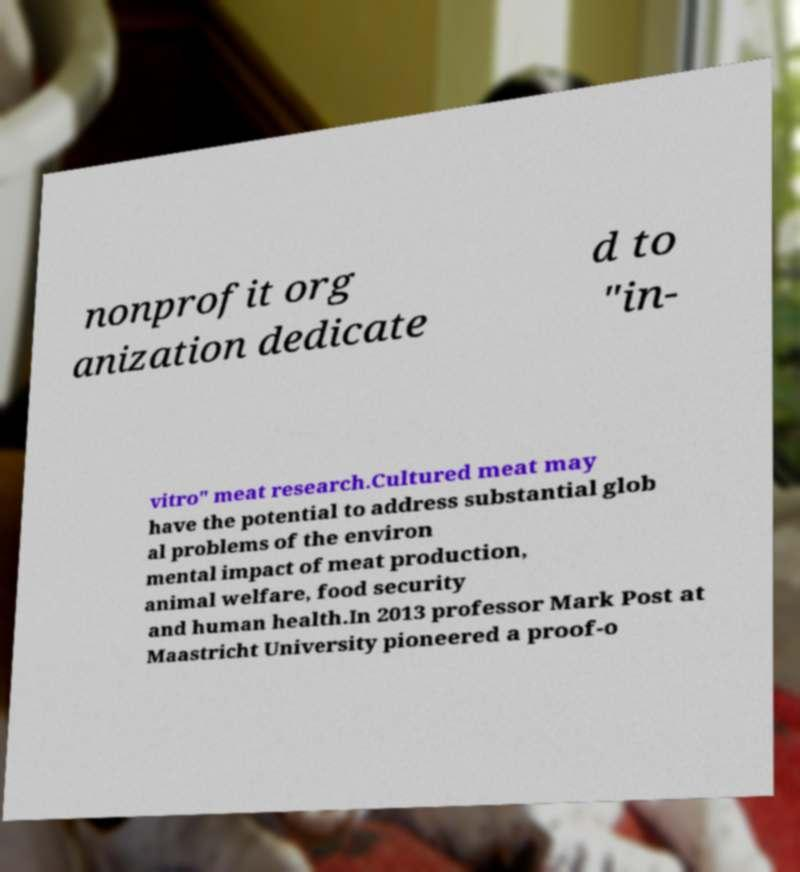Could you extract and type out the text from this image? nonprofit org anization dedicate d to "in- vitro" meat research.Cultured meat may have the potential to address substantial glob al problems of the environ mental impact of meat production, animal welfare, food security and human health.In 2013 professor Mark Post at Maastricht University pioneered a proof-o 